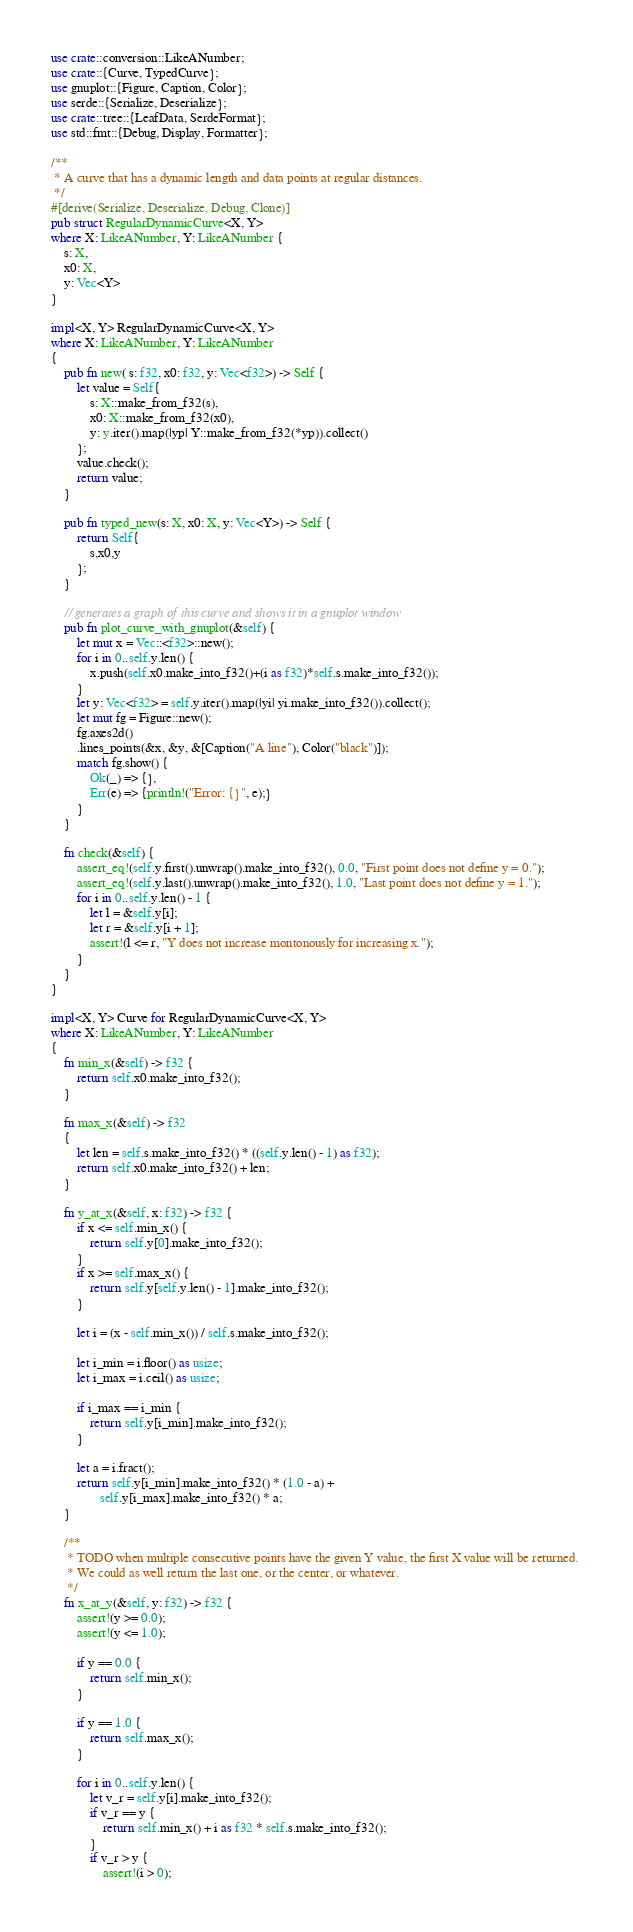Convert code to text. <code><loc_0><loc_0><loc_500><loc_500><_Rust_>use crate::conversion::LikeANumber;
use crate::{Curve, TypedCurve};
use gnuplot::{Figure, Caption, Color};
use serde::{Serialize, Deserialize};
use crate::tree::{LeafData, SerdeFormat};
use std::fmt::{Debug, Display, Formatter};

/**
 * A curve that has a dynamic length and data points at regular distances.
 */
#[derive(Serialize, Deserialize, Debug, Clone)]
pub struct RegularDynamicCurve<X, Y> 
where X: LikeANumber, Y: LikeANumber {
    s: X,
    x0: X,
    y: Vec<Y>
}

impl<X, Y> RegularDynamicCurve<X, Y>
where X: LikeANumber, Y: LikeANumber
{
    pub fn new( s: f32, x0: f32, y: Vec<f32>) -> Self {
        let value = Self{
            s: X::make_from_f32(s),
            x0: X::make_from_f32(x0),
            y: y.iter().map(|yp| Y::make_from_f32(*yp)).collect()
        };
        value.check();
        return value;
    }

    pub fn typed_new(s: X, x0: X, y: Vec<Y>) -> Self {
        return Self{
            s,x0,y
        };
    }

    // generates a graph of this curve and shows it in a gnuplot window
    pub fn plot_curve_with_gnuplot(&self) {
        let mut x = Vec::<f32>::new();
        for i in 0..self.y.len() {
            x.push(self.x0.make_into_f32()+(i as f32)*self.s.make_into_f32());
        }
        let y: Vec<f32> = self.y.iter().map(|yi| yi.make_into_f32()).collect();
        let mut fg = Figure::new();
        fg.axes2d()
        .lines_points(&x, &y, &[Caption("A line"), Color("black")]);
        match fg.show() {
            Ok(_) => {},
            Err(e) => {println!("Error: {}", e);}
        }
    }

    fn check(&self) {
        assert_eq!(self.y.first().unwrap().make_into_f32(), 0.0, "First point does not define y = 0.");
        assert_eq!(self.y.last().unwrap().make_into_f32(), 1.0, "Last point does not define y = 1.");
        for i in 0..self.y.len() - 1 {
            let l = &self.y[i];
            let r = &self.y[i + 1];
            assert!(l <= r, "Y does not increase montonously for increasing x.");
        }
    }
}

impl<X, Y> Curve for RegularDynamicCurve<X, Y>
where X: LikeANumber, Y: LikeANumber
{
    fn min_x(&self) -> f32 {
        return self.x0.make_into_f32();
    }

    fn max_x(&self) -> f32
    {
        let len = self.s.make_into_f32() * ((self.y.len() - 1) as f32);
        return self.x0.make_into_f32() + len;
    }

    fn y_at_x(&self, x: f32) -> f32 {
        if x <= self.min_x() {
            return self.y[0].make_into_f32();
        }
        if x >= self.max_x() {
            return self.y[self.y.len() - 1].make_into_f32();
        }

        let i = (x - self.min_x()) / self.s.make_into_f32();
       
        let i_min = i.floor() as usize;
        let i_max = i.ceil() as usize;

        if i_max == i_min {
            return self.y[i_min].make_into_f32();
        }

        let a = i.fract();
        return self.y[i_min].make_into_f32() * (1.0 - a) + 
               self.y[i_max].make_into_f32() * a;
    }

    /**
     * TODO when multiple consecutive points have the given Y value, the first X value will be returned. 
     * We could as well return the last one, or the center, or whatever.
     */
    fn x_at_y(&self, y: f32) -> f32 {
        assert!(y >= 0.0);
        assert!(y <= 1.0);

        if y == 0.0 {
            return self.min_x();
        }

        if y == 1.0 {
            return self.max_x();
        }

        for i in 0..self.y.len() {
            let v_r = self.y[i].make_into_f32();
            if v_r == y {
                return self.min_x() + i as f32 * self.s.make_into_f32();
            }
            if v_r > y {
                assert!(i > 0);</code> 